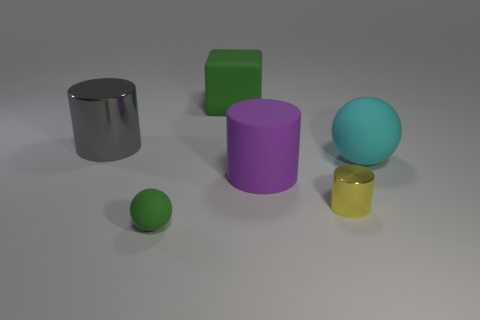Add 1 cyan matte cubes. How many objects exist? 7 Subtract 1 balls. How many balls are left? 1 Subtract all red cylinders. How many cyan balls are left? 1 Subtract all gray objects. Subtract all large green objects. How many objects are left? 4 Add 3 big cyan matte spheres. How many big cyan matte spheres are left? 4 Add 4 small red rubber cylinders. How many small red rubber cylinders exist? 4 Subtract all gray cylinders. How many cylinders are left? 2 Subtract all metallic cylinders. How many cylinders are left? 1 Subtract 0 yellow balls. How many objects are left? 6 Subtract all cubes. How many objects are left? 5 